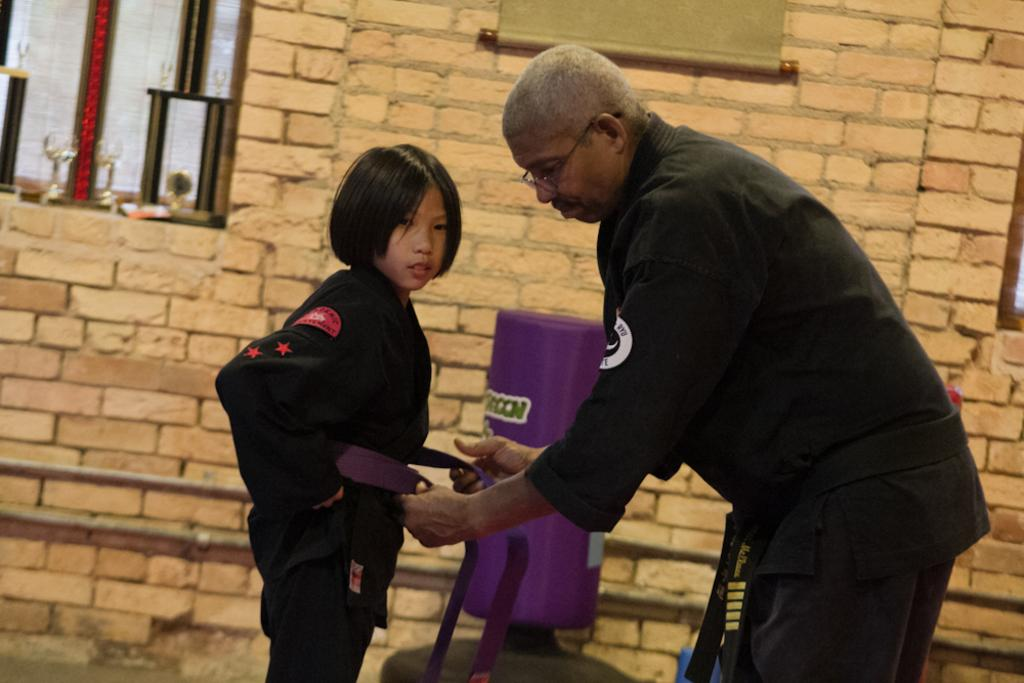Who are the people in the image? There is a man and a girl in the image. What can be seen in the background of the image? There is a wall in the background of the image. What accessory is visible on the man in the image? There is a belt visible in the image. Where are the glasses located in the image? There are two glasses on the left side of the image. What type of bears can be seen in the cemetery in the image? There is no cemetery or bears present in the image. 